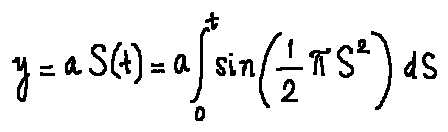<formula> <loc_0><loc_0><loc_500><loc_500>y = a S ( t ) = a \int \lim i t s _ { 0 } ^ { t } \sin ( \frac { 1 } { 2 } \pi s ^ { 2 } ) d s</formula> 